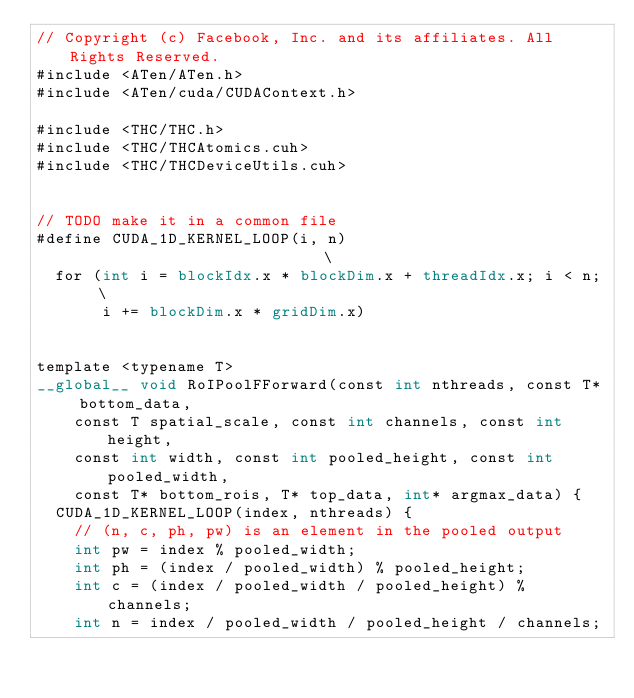Convert code to text. <code><loc_0><loc_0><loc_500><loc_500><_Cuda_>// Copyright (c) Facebook, Inc. and its affiliates. All Rights Reserved.
#include <ATen/ATen.h>
#include <ATen/cuda/CUDAContext.h>

#include <THC/THC.h>
#include <THC/THCAtomics.cuh>
#include <THC/THCDeviceUtils.cuh>


// TODO make it in a common file
#define CUDA_1D_KERNEL_LOOP(i, n)                            \
  for (int i = blockIdx.x * blockDim.x + threadIdx.x; i < n; \
       i += blockDim.x * gridDim.x)


template <typename T>
__global__ void RoIPoolFForward(const int nthreads, const T* bottom_data,
    const T spatial_scale, const int channels, const int height,
    const int width, const int pooled_height, const int pooled_width,
    const T* bottom_rois, T* top_data, int* argmax_data) {
  CUDA_1D_KERNEL_LOOP(index, nthreads) {
    // (n, c, ph, pw) is an element in the pooled output
    int pw = index % pooled_width;
    int ph = (index / pooled_width) % pooled_height;
    int c = (index / pooled_width / pooled_height) % channels;
    int n = index / pooled_width / pooled_height / channels;
</code> 